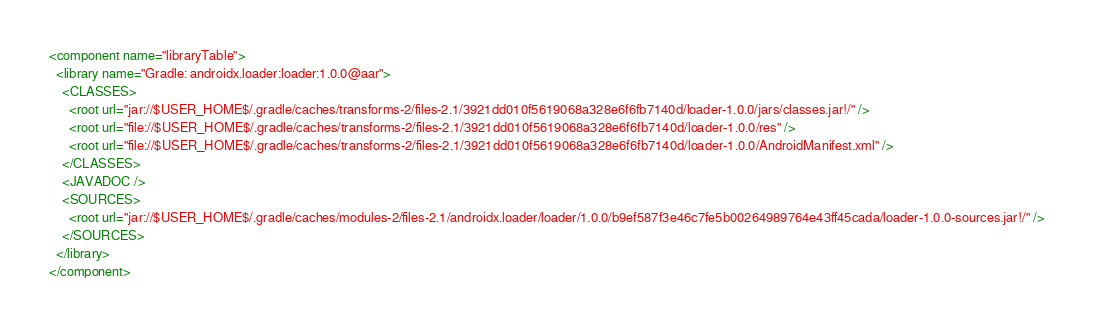<code> <loc_0><loc_0><loc_500><loc_500><_XML_><component name="libraryTable">
  <library name="Gradle: androidx.loader:loader:1.0.0@aar">
    <CLASSES>
      <root url="jar://$USER_HOME$/.gradle/caches/transforms-2/files-2.1/3921dd010f5619068a328e6f6fb7140d/loader-1.0.0/jars/classes.jar!/" />
      <root url="file://$USER_HOME$/.gradle/caches/transforms-2/files-2.1/3921dd010f5619068a328e6f6fb7140d/loader-1.0.0/res" />
      <root url="file://$USER_HOME$/.gradle/caches/transforms-2/files-2.1/3921dd010f5619068a328e6f6fb7140d/loader-1.0.0/AndroidManifest.xml" />
    </CLASSES>
    <JAVADOC />
    <SOURCES>
      <root url="jar://$USER_HOME$/.gradle/caches/modules-2/files-2.1/androidx.loader/loader/1.0.0/b9ef587f3e46c7fe5b00264989764e43ff45cada/loader-1.0.0-sources.jar!/" />
    </SOURCES>
  </library>
</component></code> 